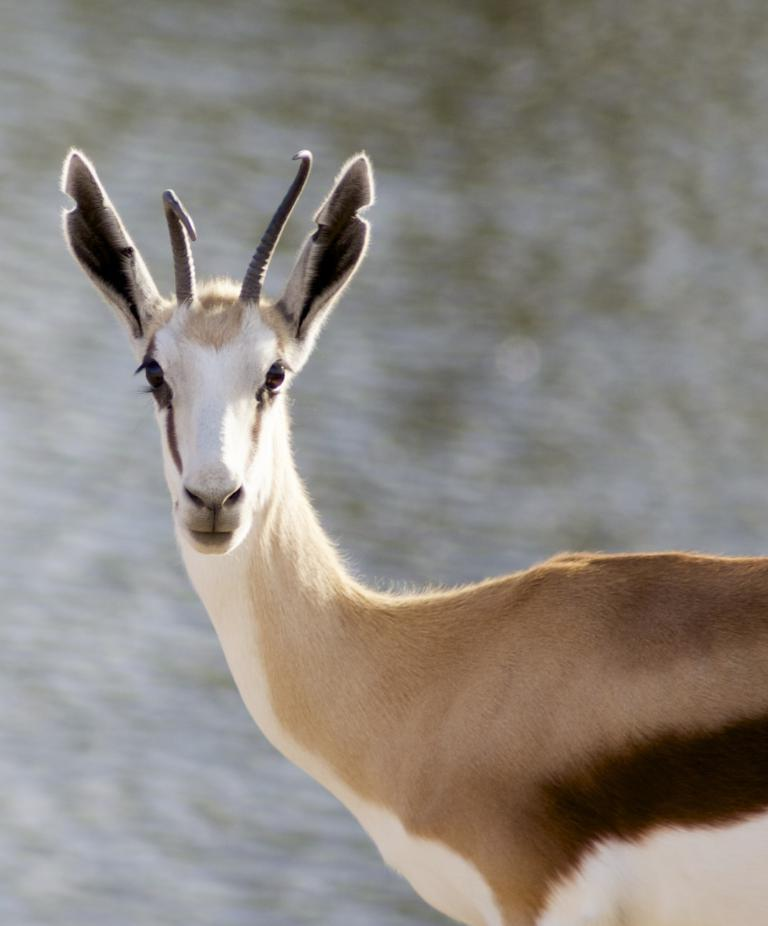What is the main subject of the image? There is an animal in the center of the image. Can you describe the background of the image? The background of the image is blurred. What type of fruit is hanging from the hose in the image? There is no fruit or hose present in the image. What word is written on the animal's forehead in the image? There is no text or word written on the animal's forehead in the image. 